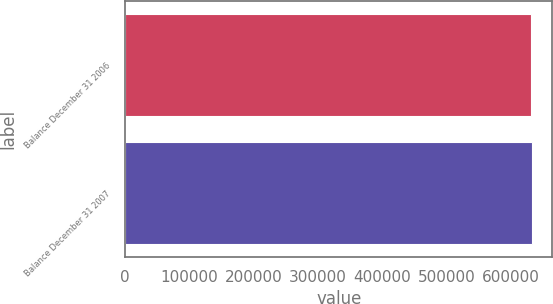<chart> <loc_0><loc_0><loc_500><loc_500><bar_chart><fcel>Balance December 31 2006<fcel>Balance December 31 2007<nl><fcel>630489<fcel>633030<nl></chart> 